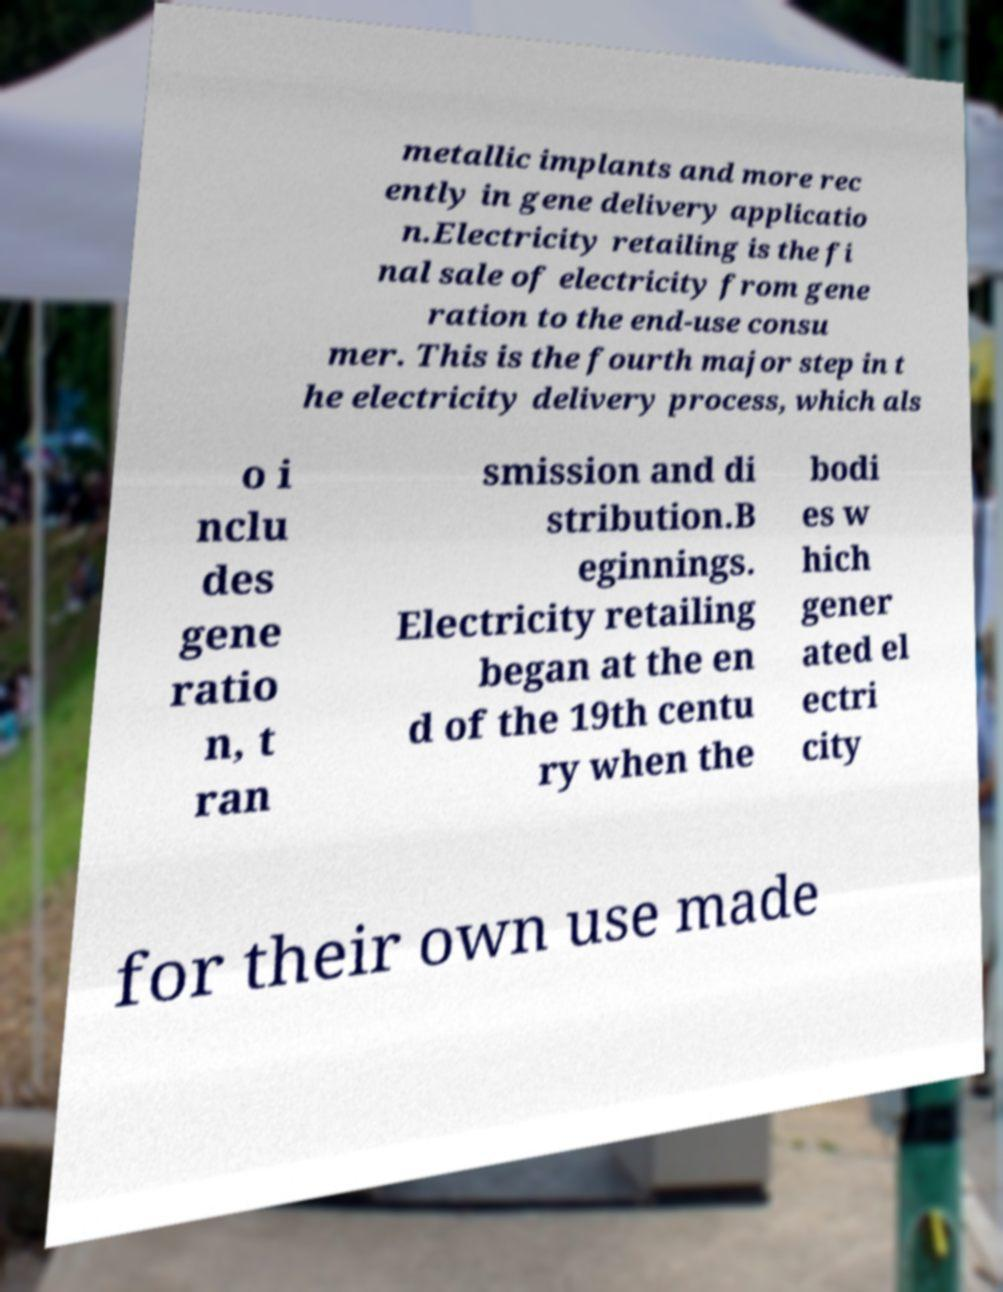Please identify and transcribe the text found in this image. metallic implants and more rec ently in gene delivery applicatio n.Electricity retailing is the fi nal sale of electricity from gene ration to the end-use consu mer. This is the fourth major step in t he electricity delivery process, which als o i nclu des gene ratio n, t ran smission and di stribution.B eginnings. Electricity retailing began at the en d of the 19th centu ry when the bodi es w hich gener ated el ectri city for their own use made 